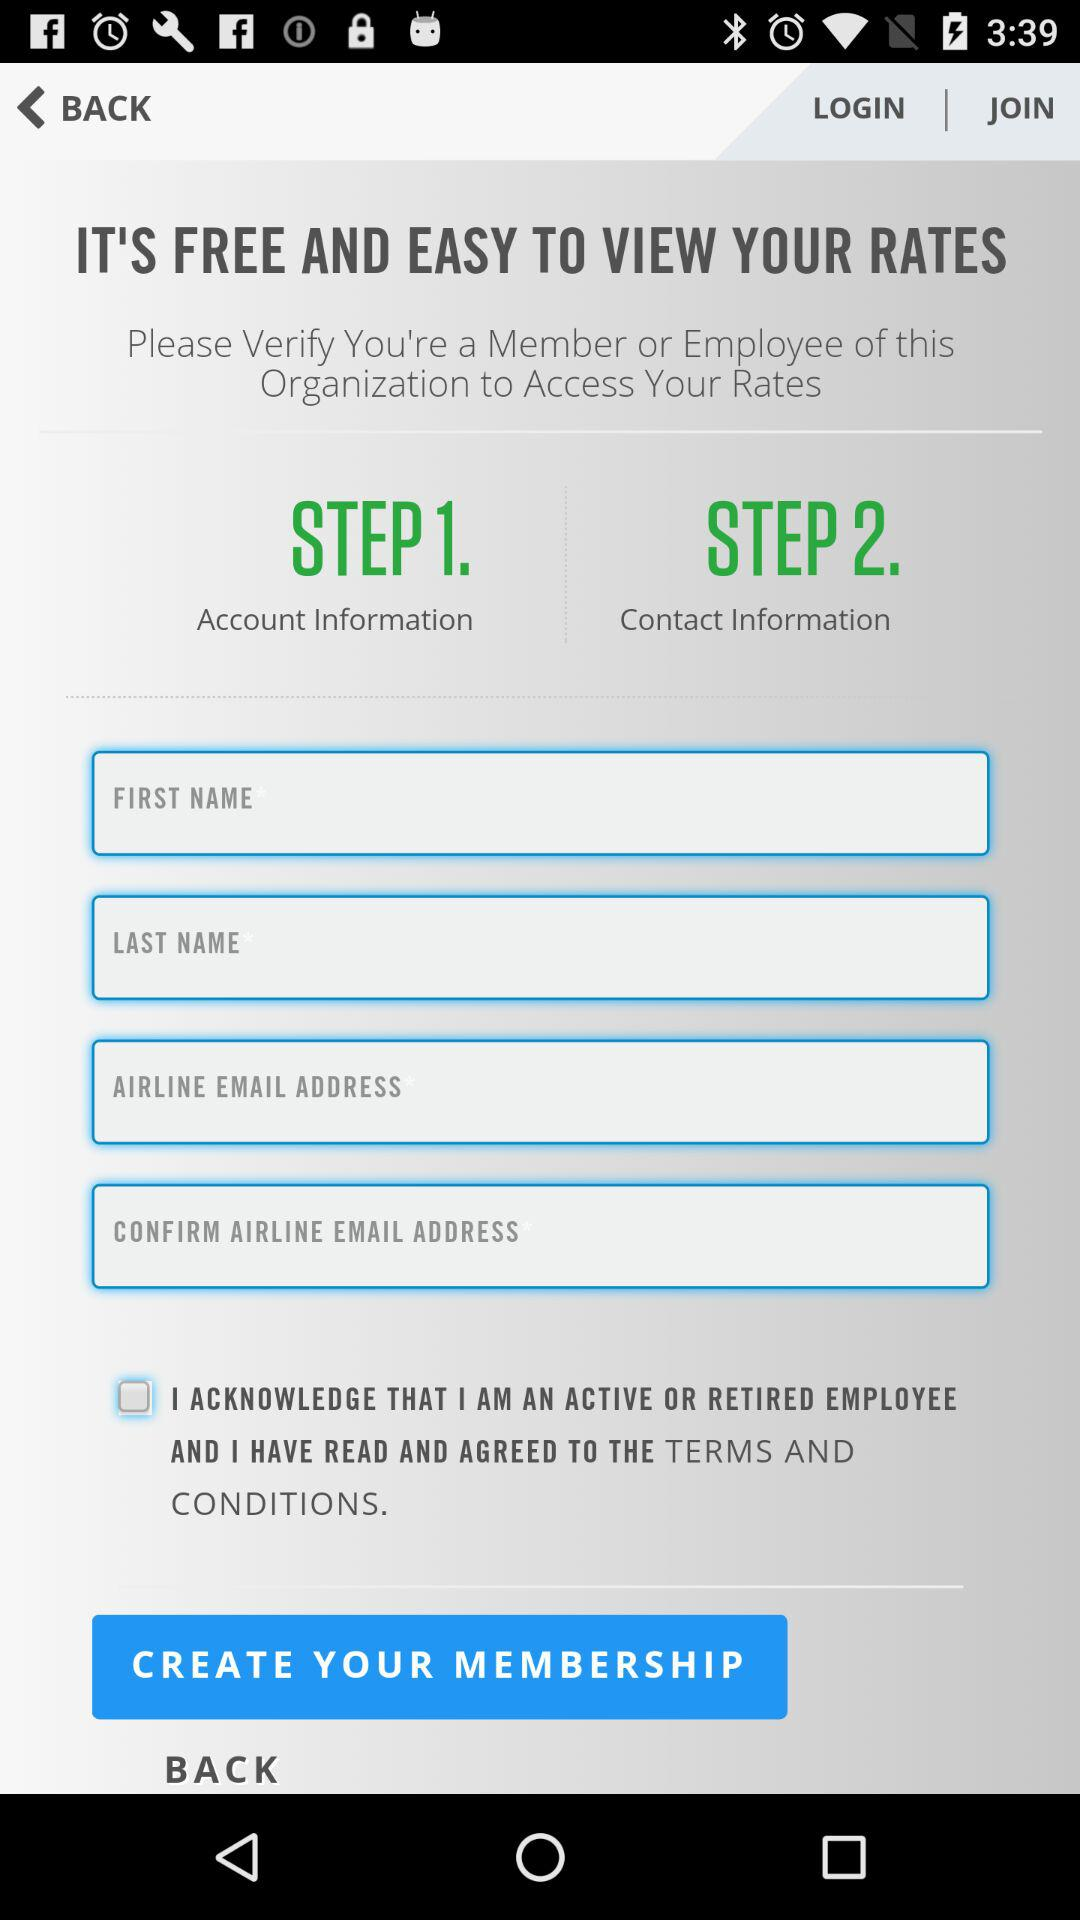What type of information is included in step one? In step one, account information is included. 